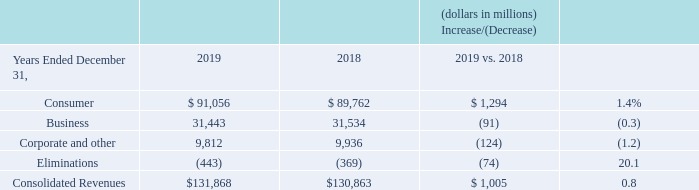Consolidated Revenues
Consolidated revenues increased $1.0 billion, or 0.8%, during 2019 compared to 2018, primarily due to an increase in revenues at our Consumer segment, partially offset by decreases in revenues at our Business segment and Corporate and other.
Revenues for our segments are discussed separately below under the heading “Segment Results of Operations.”
Corporate and other revenues decreased $124 million, or 1.2%, during 2019 compared to 2018, primarily due to a decrease of $232 million in revenues within Verizon Media.
What was the increase in the consolidated revenue from 2018 to 2019? $1.0 billion. What was the decrease in the corporate and other revenue from 2018 to 2019? $124 million. What caused the decrease in corporate and other revenue? A decrease of $232 million in revenues within verizon media. What was the change in the consumer revenue from 2018 to 2019?
Answer scale should be: million. 91,056 - 89,762
Answer: 1294. What was the average business segment revenue for 2018 and 2019?
Answer scale should be: million. (31,443 + 31,534) / 2
Answer: 31488.5. What was the average corporate segment revenue and other segment revenue for 2018 and 2019?
Answer scale should be: million. (9,812 + 9,936) / 2
Answer: 9874. 